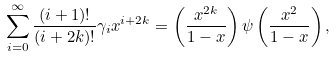Convert formula to latex. <formula><loc_0><loc_0><loc_500><loc_500>\sum _ { i = 0 } ^ { \infty } \frac { ( i + 1 ) ! } { ( i + 2 k ) ! } \gamma _ { i } x ^ { i + 2 k } = \left ( \frac { x ^ { 2 k } } { 1 - x } \right ) \psi \left ( \frac { x ^ { 2 } } { 1 - x } \right ) ,</formula> 